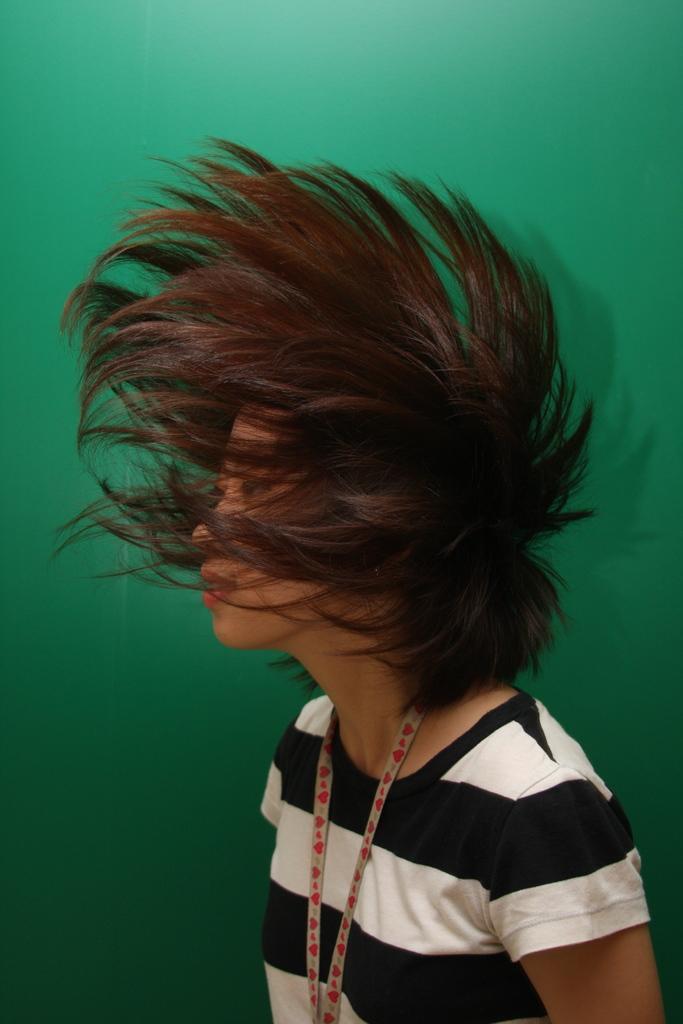In one or two sentences, can you explain what this image depicts? In this image there is a person covered his face with his hair. Background is green in colour. 